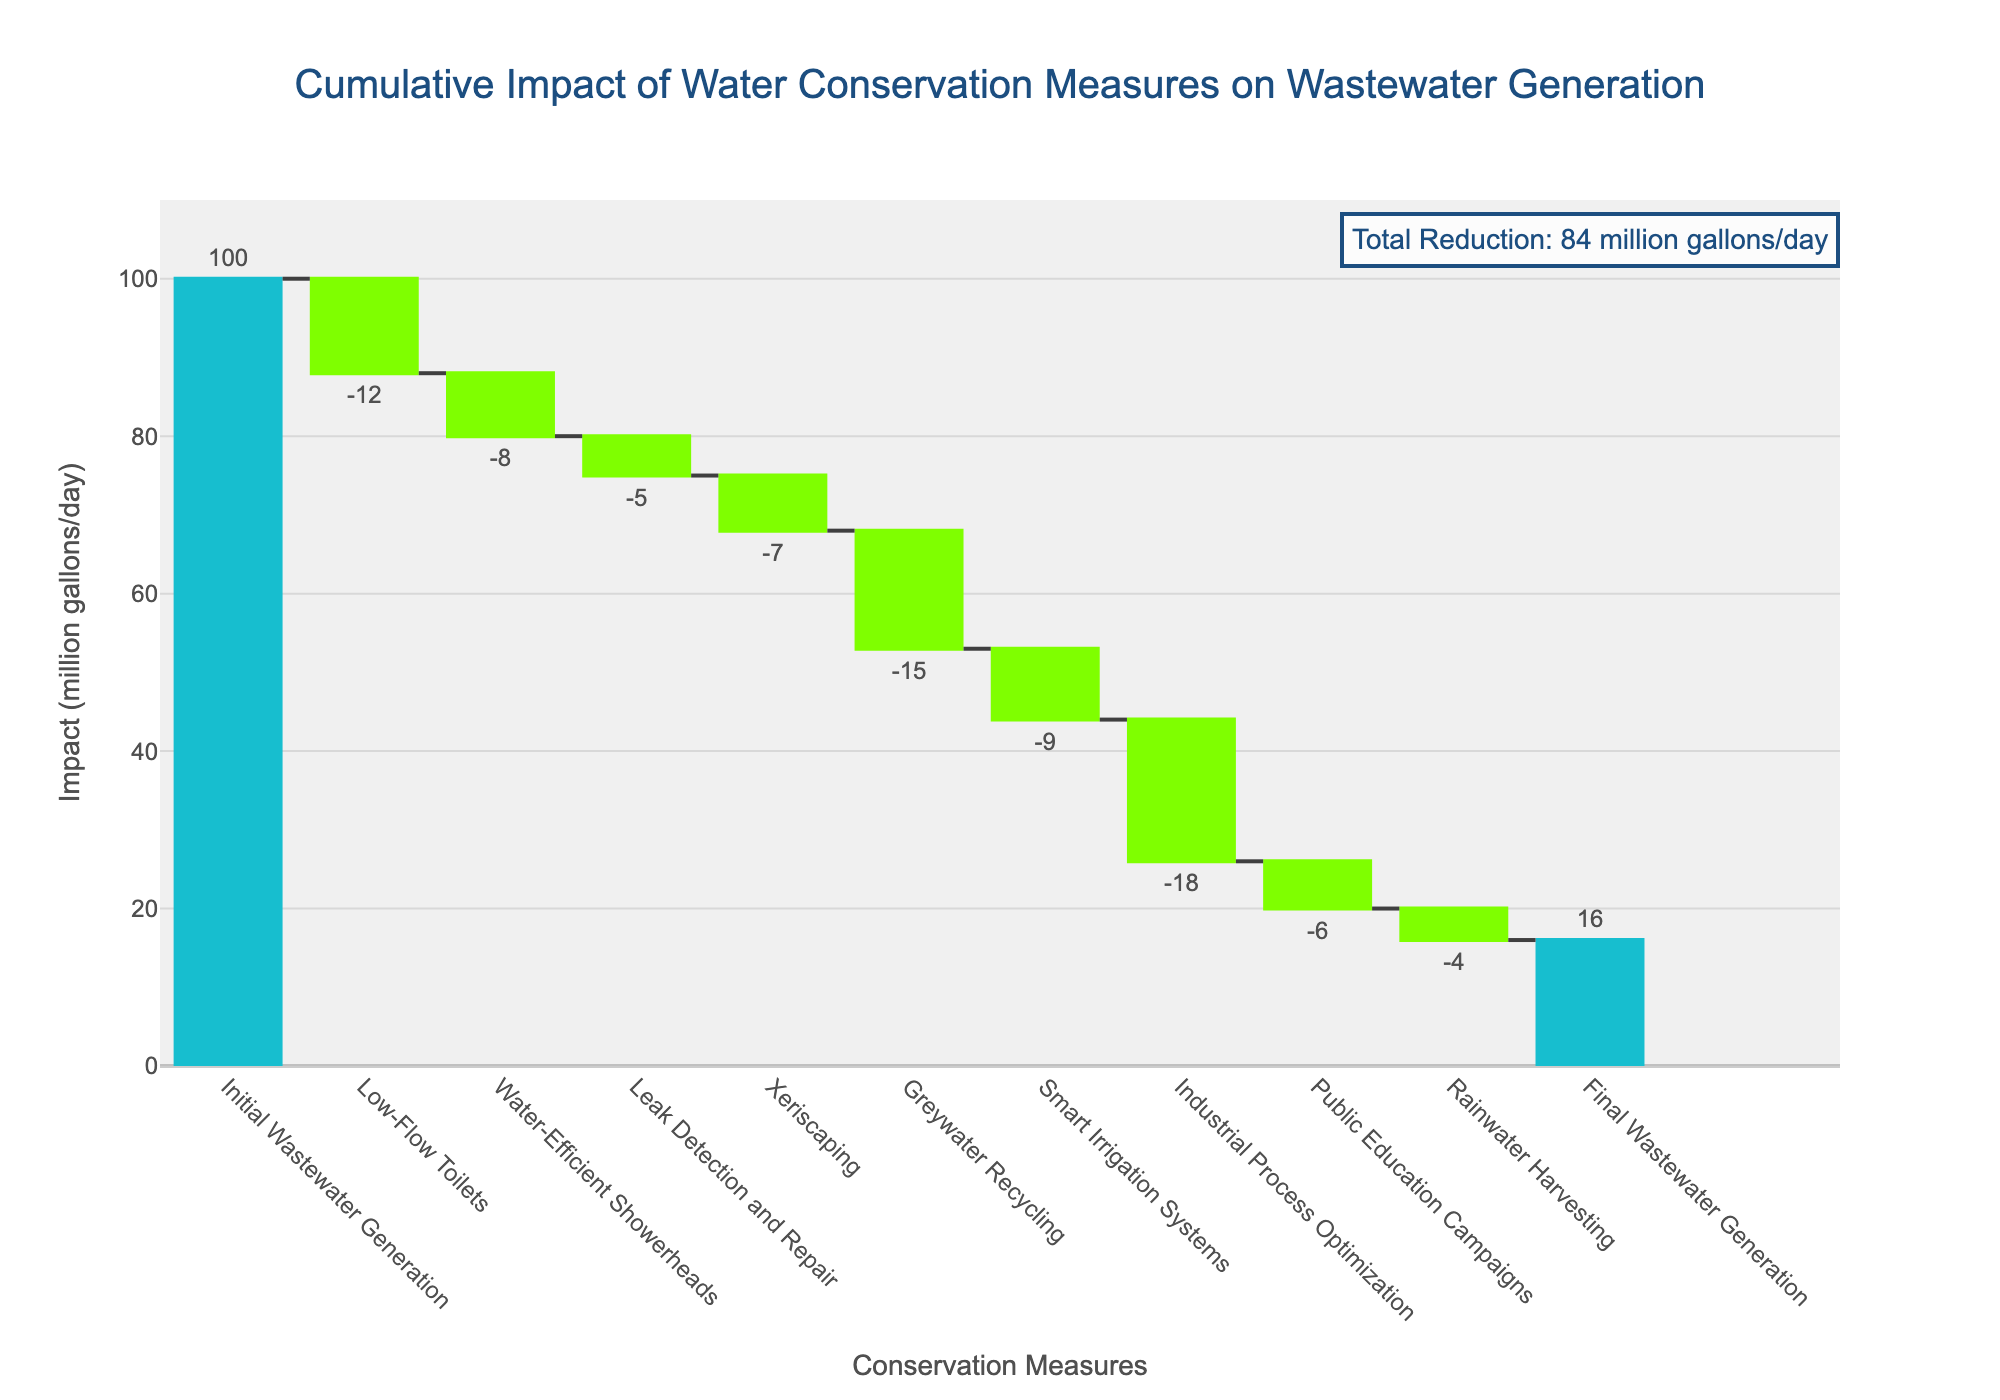What's the initial wastewater generation in million gallons per day? The initial wastewater generation is labeled as "Initial Wastewater Generation" and has the value of 100 million gallons per day.
Answer: 100 How much does greywater recycling reduce wastewater generation by? Greywater recycling is indicated by its label and shows a reduction of 15 million gallons per day.
Answer: 15 What is the final wastewater generation after all measures have been applied? The final wastewater generation is labeled "Final Wastewater Generation" and has the value of 16 million gallons per day.
Answer: 16 What is the total reduction in wastewater generation achieved by all measures combined? The total reduction can be calculated by subtracting the final wastewater generation from the initial wastewater generation, which is 100 - 16. The chart also includes an annotation with the total reduction value.
Answer: 84 Which water conservation measure has the largest impact on wastewater generation? By comparing the absolute impact values of all measures, Industrial Process Optimization has the largest impact with a reduction of 18 million gallons per day.
Answer: Industrial Process Optimization What are the cumulative impacts of Low-Flow Toilets and Water-Efficient Showerheads? The impact of Low-Flow Toilets is -12 and Water-Efficient Showerheads is -8. Adding them together gives a cumulative impact of -20 million gallons per day.
Answer: -20 Which two measures combined have an impact equal to or greater than Greywater Recycling's impact? Greywater Recycling has an impact of -15 million gallons/day. Adding the impacts of Smart Irrigation Systems (-9) and Rainwater Harvesting (-4) yields -13, which is less than -15. Including the Public Education Campaigns (-6) with Smart Irrigation Systems gives -15, matching Greywater Recycling's impact. So the measures are Smart Irrigation Systems and Public Education Campaigns.
Answer: Smart Irrigation Systems and Public Education Campaigns How does the impact of water-efficient showerheads compare with leak detection and repair? Water-Efficient Showerheads reduce the wastewater by 8 million gallons/day, whereas Leak Detection and Repair reduces it by 5 million gallons/day. Comparing these values, Water-Efficient Showerheads have a higher impact.
Answer: Water-Efficient Showerheads have a higher impact What measure shows the smallest reduction in wastewater generation? Reviewing all the impact values, the Rainwater Harvesting measure shows the smallest reduction of 4 million gallons/day.
Answer: Rainwater Harvesting What is the percentage reduction in wastewater generation due to Xeriscaping? Xeriscaping reduces wastewater by 7 million gallons/day. To find the percentage reduction: (7 / 100) * 100 = 7%.
Answer: 7% 